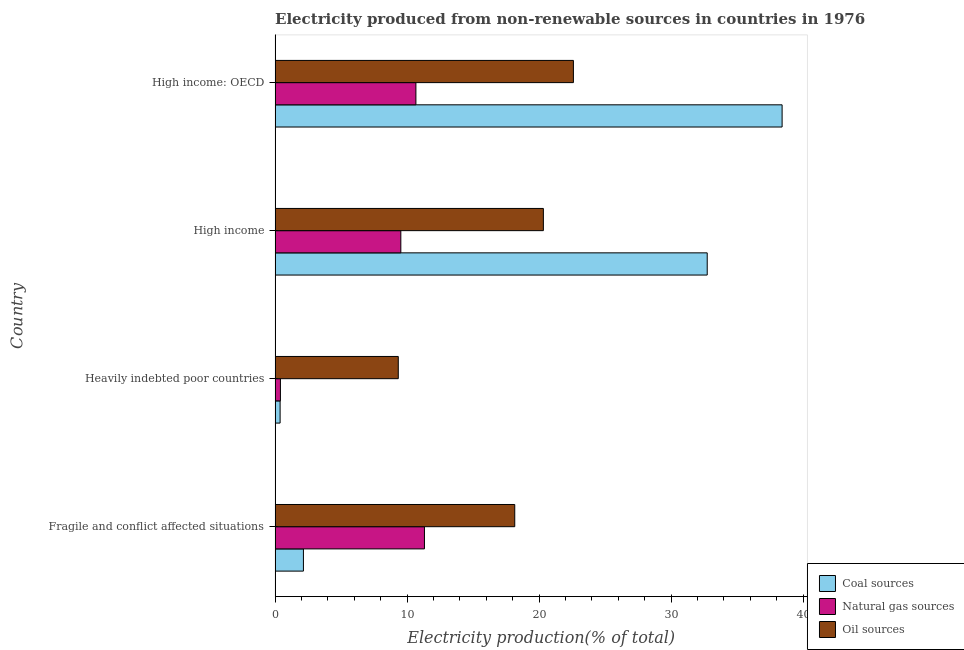How many groups of bars are there?
Offer a very short reply. 4. Are the number of bars on each tick of the Y-axis equal?
Provide a succinct answer. Yes. How many bars are there on the 3rd tick from the bottom?
Give a very brief answer. 3. What is the label of the 2nd group of bars from the top?
Provide a short and direct response. High income. What is the percentage of electricity produced by natural gas in High income?
Your answer should be compact. 9.53. Across all countries, what is the maximum percentage of electricity produced by natural gas?
Provide a succinct answer. 11.32. Across all countries, what is the minimum percentage of electricity produced by natural gas?
Make the answer very short. 0.41. In which country was the percentage of electricity produced by coal maximum?
Offer a terse response. High income: OECD. In which country was the percentage of electricity produced by coal minimum?
Ensure brevity in your answer.  Heavily indebted poor countries. What is the total percentage of electricity produced by coal in the graph?
Offer a very short reply. 73.69. What is the difference between the percentage of electricity produced by coal in High income and that in High income: OECD?
Offer a terse response. -5.67. What is the difference between the percentage of electricity produced by coal in High income and the percentage of electricity produced by oil sources in Fragile and conflict affected situations?
Your answer should be compact. 14.58. What is the average percentage of electricity produced by oil sources per country?
Offer a very short reply. 17.61. What is the difference between the percentage of electricity produced by coal and percentage of electricity produced by natural gas in Heavily indebted poor countries?
Give a very brief answer. -0.02. What is the ratio of the percentage of electricity produced by oil sources in High income to that in High income: OECD?
Keep it short and to the point. 0.9. What is the difference between the highest and the second highest percentage of electricity produced by coal?
Provide a short and direct response. 5.67. What is the difference between the highest and the lowest percentage of electricity produced by oil sources?
Provide a short and direct response. 13.27. In how many countries, is the percentage of electricity produced by natural gas greater than the average percentage of electricity produced by natural gas taken over all countries?
Provide a succinct answer. 3. What does the 2nd bar from the top in Heavily indebted poor countries represents?
Provide a short and direct response. Natural gas sources. What does the 1st bar from the bottom in High income: OECD represents?
Ensure brevity in your answer.  Coal sources. How many bars are there?
Your answer should be very brief. 12. How many countries are there in the graph?
Ensure brevity in your answer.  4. What is the difference between two consecutive major ticks on the X-axis?
Provide a succinct answer. 10. Does the graph contain any zero values?
Ensure brevity in your answer.  No. Does the graph contain grids?
Keep it short and to the point. No. How many legend labels are there?
Offer a terse response. 3. How are the legend labels stacked?
Give a very brief answer. Vertical. What is the title of the graph?
Your answer should be compact. Electricity produced from non-renewable sources in countries in 1976. Does "Ages 65 and above" appear as one of the legend labels in the graph?
Your answer should be compact. No. What is the Electricity production(% of total) of Coal sources in Fragile and conflict affected situations?
Ensure brevity in your answer.  2.15. What is the Electricity production(% of total) of Natural gas sources in Fragile and conflict affected situations?
Offer a terse response. 11.32. What is the Electricity production(% of total) of Oil sources in Fragile and conflict affected situations?
Ensure brevity in your answer.  18.16. What is the Electricity production(% of total) in Coal sources in Heavily indebted poor countries?
Make the answer very short. 0.38. What is the Electricity production(% of total) in Natural gas sources in Heavily indebted poor countries?
Ensure brevity in your answer.  0.41. What is the Electricity production(% of total) in Oil sources in Heavily indebted poor countries?
Make the answer very short. 9.33. What is the Electricity production(% of total) of Coal sources in High income?
Give a very brief answer. 32.74. What is the Electricity production(% of total) in Natural gas sources in High income?
Provide a short and direct response. 9.53. What is the Electricity production(% of total) in Oil sources in High income?
Provide a short and direct response. 20.33. What is the Electricity production(% of total) of Coal sources in High income: OECD?
Give a very brief answer. 38.42. What is the Electricity production(% of total) in Natural gas sources in High income: OECD?
Give a very brief answer. 10.67. What is the Electricity production(% of total) of Oil sources in High income: OECD?
Provide a short and direct response. 22.6. Across all countries, what is the maximum Electricity production(% of total) of Coal sources?
Make the answer very short. 38.42. Across all countries, what is the maximum Electricity production(% of total) in Natural gas sources?
Make the answer very short. 11.32. Across all countries, what is the maximum Electricity production(% of total) in Oil sources?
Give a very brief answer. 22.6. Across all countries, what is the minimum Electricity production(% of total) of Coal sources?
Provide a succinct answer. 0.38. Across all countries, what is the minimum Electricity production(% of total) of Natural gas sources?
Ensure brevity in your answer.  0.41. Across all countries, what is the minimum Electricity production(% of total) in Oil sources?
Provide a short and direct response. 9.33. What is the total Electricity production(% of total) in Coal sources in the graph?
Offer a very short reply. 73.69. What is the total Electricity production(% of total) of Natural gas sources in the graph?
Offer a terse response. 31.92. What is the total Electricity production(% of total) of Oil sources in the graph?
Your answer should be compact. 70.43. What is the difference between the Electricity production(% of total) in Coal sources in Fragile and conflict affected situations and that in Heavily indebted poor countries?
Keep it short and to the point. 1.77. What is the difference between the Electricity production(% of total) in Natural gas sources in Fragile and conflict affected situations and that in Heavily indebted poor countries?
Offer a terse response. 10.91. What is the difference between the Electricity production(% of total) in Oil sources in Fragile and conflict affected situations and that in Heavily indebted poor countries?
Give a very brief answer. 8.82. What is the difference between the Electricity production(% of total) in Coal sources in Fragile and conflict affected situations and that in High income?
Provide a succinct answer. -30.59. What is the difference between the Electricity production(% of total) of Natural gas sources in Fragile and conflict affected situations and that in High income?
Ensure brevity in your answer.  1.79. What is the difference between the Electricity production(% of total) of Oil sources in Fragile and conflict affected situations and that in High income?
Your answer should be compact. -2.17. What is the difference between the Electricity production(% of total) of Coal sources in Fragile and conflict affected situations and that in High income: OECD?
Offer a terse response. -36.27. What is the difference between the Electricity production(% of total) in Natural gas sources in Fragile and conflict affected situations and that in High income: OECD?
Provide a short and direct response. 0.65. What is the difference between the Electricity production(% of total) of Oil sources in Fragile and conflict affected situations and that in High income: OECD?
Offer a very short reply. -4.44. What is the difference between the Electricity production(% of total) in Coal sources in Heavily indebted poor countries and that in High income?
Give a very brief answer. -32.36. What is the difference between the Electricity production(% of total) in Natural gas sources in Heavily indebted poor countries and that in High income?
Offer a terse response. -9.12. What is the difference between the Electricity production(% of total) in Oil sources in Heavily indebted poor countries and that in High income?
Provide a short and direct response. -10.99. What is the difference between the Electricity production(% of total) in Coal sources in Heavily indebted poor countries and that in High income: OECD?
Provide a succinct answer. -38.03. What is the difference between the Electricity production(% of total) of Natural gas sources in Heavily indebted poor countries and that in High income: OECD?
Ensure brevity in your answer.  -10.27. What is the difference between the Electricity production(% of total) of Oil sources in Heavily indebted poor countries and that in High income: OECD?
Give a very brief answer. -13.27. What is the difference between the Electricity production(% of total) in Coal sources in High income and that in High income: OECD?
Ensure brevity in your answer.  -5.67. What is the difference between the Electricity production(% of total) of Natural gas sources in High income and that in High income: OECD?
Your answer should be compact. -1.14. What is the difference between the Electricity production(% of total) of Oil sources in High income and that in High income: OECD?
Your response must be concise. -2.28. What is the difference between the Electricity production(% of total) in Coal sources in Fragile and conflict affected situations and the Electricity production(% of total) in Natural gas sources in Heavily indebted poor countries?
Provide a succinct answer. 1.74. What is the difference between the Electricity production(% of total) in Coal sources in Fragile and conflict affected situations and the Electricity production(% of total) in Oil sources in Heavily indebted poor countries?
Give a very brief answer. -7.19. What is the difference between the Electricity production(% of total) of Natural gas sources in Fragile and conflict affected situations and the Electricity production(% of total) of Oil sources in Heavily indebted poor countries?
Offer a very short reply. 1.98. What is the difference between the Electricity production(% of total) of Coal sources in Fragile and conflict affected situations and the Electricity production(% of total) of Natural gas sources in High income?
Provide a succinct answer. -7.38. What is the difference between the Electricity production(% of total) in Coal sources in Fragile and conflict affected situations and the Electricity production(% of total) in Oil sources in High income?
Offer a very short reply. -18.18. What is the difference between the Electricity production(% of total) of Natural gas sources in Fragile and conflict affected situations and the Electricity production(% of total) of Oil sources in High income?
Offer a very short reply. -9.01. What is the difference between the Electricity production(% of total) of Coal sources in Fragile and conflict affected situations and the Electricity production(% of total) of Natural gas sources in High income: OECD?
Your response must be concise. -8.52. What is the difference between the Electricity production(% of total) in Coal sources in Fragile and conflict affected situations and the Electricity production(% of total) in Oil sources in High income: OECD?
Your answer should be very brief. -20.46. What is the difference between the Electricity production(% of total) of Natural gas sources in Fragile and conflict affected situations and the Electricity production(% of total) of Oil sources in High income: OECD?
Your response must be concise. -11.29. What is the difference between the Electricity production(% of total) of Coal sources in Heavily indebted poor countries and the Electricity production(% of total) of Natural gas sources in High income?
Keep it short and to the point. -9.15. What is the difference between the Electricity production(% of total) of Coal sources in Heavily indebted poor countries and the Electricity production(% of total) of Oil sources in High income?
Give a very brief answer. -19.95. What is the difference between the Electricity production(% of total) in Natural gas sources in Heavily indebted poor countries and the Electricity production(% of total) in Oil sources in High income?
Provide a succinct answer. -19.92. What is the difference between the Electricity production(% of total) of Coal sources in Heavily indebted poor countries and the Electricity production(% of total) of Natural gas sources in High income: OECD?
Ensure brevity in your answer.  -10.29. What is the difference between the Electricity production(% of total) of Coal sources in Heavily indebted poor countries and the Electricity production(% of total) of Oil sources in High income: OECD?
Your answer should be compact. -22.22. What is the difference between the Electricity production(% of total) of Natural gas sources in Heavily indebted poor countries and the Electricity production(% of total) of Oil sources in High income: OECD?
Offer a very short reply. -22.2. What is the difference between the Electricity production(% of total) of Coal sources in High income and the Electricity production(% of total) of Natural gas sources in High income: OECD?
Your answer should be compact. 22.07. What is the difference between the Electricity production(% of total) of Coal sources in High income and the Electricity production(% of total) of Oil sources in High income: OECD?
Keep it short and to the point. 10.14. What is the difference between the Electricity production(% of total) of Natural gas sources in High income and the Electricity production(% of total) of Oil sources in High income: OECD?
Ensure brevity in your answer.  -13.08. What is the average Electricity production(% of total) in Coal sources per country?
Provide a succinct answer. 18.42. What is the average Electricity production(% of total) of Natural gas sources per country?
Ensure brevity in your answer.  7.98. What is the average Electricity production(% of total) of Oil sources per country?
Offer a terse response. 17.61. What is the difference between the Electricity production(% of total) in Coal sources and Electricity production(% of total) in Natural gas sources in Fragile and conflict affected situations?
Provide a succinct answer. -9.17. What is the difference between the Electricity production(% of total) of Coal sources and Electricity production(% of total) of Oil sources in Fragile and conflict affected situations?
Your answer should be compact. -16.01. What is the difference between the Electricity production(% of total) of Natural gas sources and Electricity production(% of total) of Oil sources in Fragile and conflict affected situations?
Provide a succinct answer. -6.84. What is the difference between the Electricity production(% of total) in Coal sources and Electricity production(% of total) in Natural gas sources in Heavily indebted poor countries?
Your answer should be compact. -0.02. What is the difference between the Electricity production(% of total) in Coal sources and Electricity production(% of total) in Oil sources in Heavily indebted poor countries?
Make the answer very short. -8.95. What is the difference between the Electricity production(% of total) of Natural gas sources and Electricity production(% of total) of Oil sources in Heavily indebted poor countries?
Provide a succinct answer. -8.93. What is the difference between the Electricity production(% of total) of Coal sources and Electricity production(% of total) of Natural gas sources in High income?
Keep it short and to the point. 23.21. What is the difference between the Electricity production(% of total) in Coal sources and Electricity production(% of total) in Oil sources in High income?
Make the answer very short. 12.41. What is the difference between the Electricity production(% of total) of Natural gas sources and Electricity production(% of total) of Oil sources in High income?
Give a very brief answer. -10.8. What is the difference between the Electricity production(% of total) in Coal sources and Electricity production(% of total) in Natural gas sources in High income: OECD?
Your response must be concise. 27.75. What is the difference between the Electricity production(% of total) of Coal sources and Electricity production(% of total) of Oil sources in High income: OECD?
Ensure brevity in your answer.  15.81. What is the difference between the Electricity production(% of total) in Natural gas sources and Electricity production(% of total) in Oil sources in High income: OECD?
Offer a very short reply. -11.93. What is the ratio of the Electricity production(% of total) of Coal sources in Fragile and conflict affected situations to that in Heavily indebted poor countries?
Give a very brief answer. 5.63. What is the ratio of the Electricity production(% of total) of Natural gas sources in Fragile and conflict affected situations to that in Heavily indebted poor countries?
Offer a terse response. 27.93. What is the ratio of the Electricity production(% of total) in Oil sources in Fragile and conflict affected situations to that in Heavily indebted poor countries?
Ensure brevity in your answer.  1.95. What is the ratio of the Electricity production(% of total) in Coal sources in Fragile and conflict affected situations to that in High income?
Your answer should be compact. 0.07. What is the ratio of the Electricity production(% of total) in Natural gas sources in Fragile and conflict affected situations to that in High income?
Give a very brief answer. 1.19. What is the ratio of the Electricity production(% of total) of Oil sources in Fragile and conflict affected situations to that in High income?
Ensure brevity in your answer.  0.89. What is the ratio of the Electricity production(% of total) in Coal sources in Fragile and conflict affected situations to that in High income: OECD?
Provide a short and direct response. 0.06. What is the ratio of the Electricity production(% of total) of Natural gas sources in Fragile and conflict affected situations to that in High income: OECD?
Offer a very short reply. 1.06. What is the ratio of the Electricity production(% of total) of Oil sources in Fragile and conflict affected situations to that in High income: OECD?
Make the answer very short. 0.8. What is the ratio of the Electricity production(% of total) in Coal sources in Heavily indebted poor countries to that in High income?
Give a very brief answer. 0.01. What is the ratio of the Electricity production(% of total) of Natural gas sources in Heavily indebted poor countries to that in High income?
Provide a short and direct response. 0.04. What is the ratio of the Electricity production(% of total) in Oil sources in Heavily indebted poor countries to that in High income?
Give a very brief answer. 0.46. What is the ratio of the Electricity production(% of total) of Coal sources in Heavily indebted poor countries to that in High income: OECD?
Offer a terse response. 0.01. What is the ratio of the Electricity production(% of total) in Natural gas sources in Heavily indebted poor countries to that in High income: OECD?
Give a very brief answer. 0.04. What is the ratio of the Electricity production(% of total) of Oil sources in Heavily indebted poor countries to that in High income: OECD?
Ensure brevity in your answer.  0.41. What is the ratio of the Electricity production(% of total) in Coal sources in High income to that in High income: OECD?
Keep it short and to the point. 0.85. What is the ratio of the Electricity production(% of total) of Natural gas sources in High income to that in High income: OECD?
Provide a short and direct response. 0.89. What is the ratio of the Electricity production(% of total) in Oil sources in High income to that in High income: OECD?
Provide a succinct answer. 0.9. What is the difference between the highest and the second highest Electricity production(% of total) of Coal sources?
Provide a short and direct response. 5.67. What is the difference between the highest and the second highest Electricity production(% of total) of Natural gas sources?
Give a very brief answer. 0.65. What is the difference between the highest and the second highest Electricity production(% of total) of Oil sources?
Offer a very short reply. 2.28. What is the difference between the highest and the lowest Electricity production(% of total) in Coal sources?
Provide a short and direct response. 38.03. What is the difference between the highest and the lowest Electricity production(% of total) of Natural gas sources?
Provide a succinct answer. 10.91. What is the difference between the highest and the lowest Electricity production(% of total) in Oil sources?
Your answer should be compact. 13.27. 